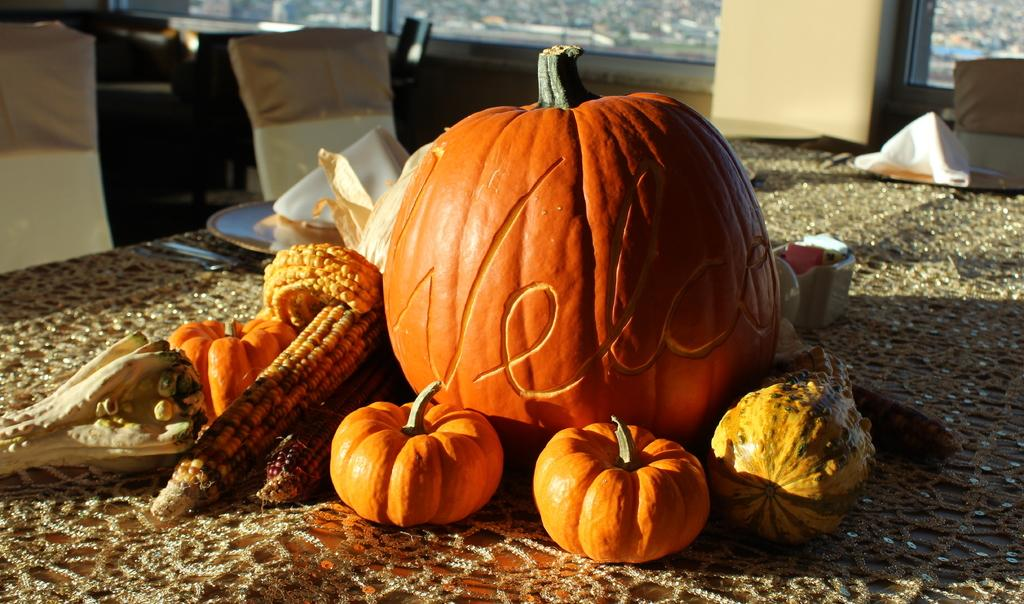What type of food can be seen on the table in the image? There are fruits on the table in the image. What type of furniture is visible in the image? There are chairs visible in the image. Are there any bears visible in the image? No, there are no bears present in the image. What type of team is playing in the image? There is no team or any indication of a game or sport in the image. 